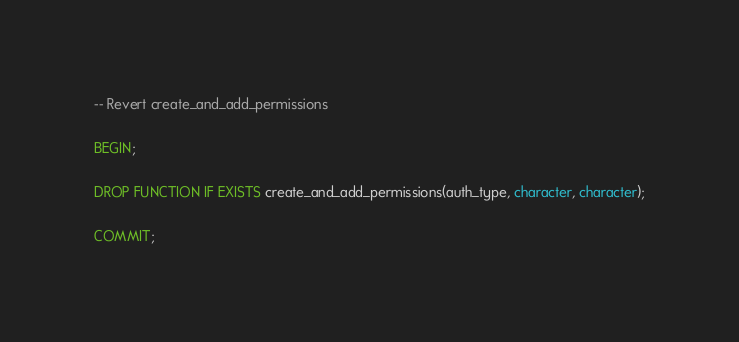<code> <loc_0><loc_0><loc_500><loc_500><_SQL_>-- Revert create_and_add_permissions

BEGIN;

DROP FUNCTION IF EXISTS create_and_add_permissions(auth_type, character, character);

COMMIT;
</code> 